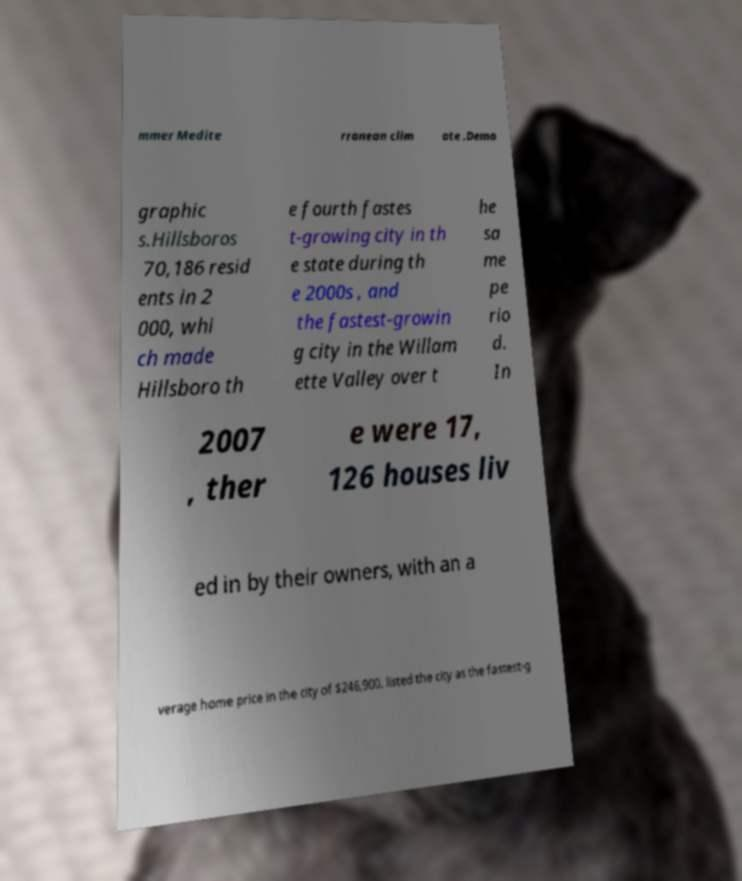Can you read and provide the text displayed in the image?This photo seems to have some interesting text. Can you extract and type it out for me? mmer Medite rranean clim ate .Demo graphic s.Hillsboros 70,186 resid ents in 2 000, whi ch made Hillsboro th e fourth fastes t-growing city in th e state during th e 2000s , and the fastest-growin g city in the Willam ette Valley over t he sa me pe rio d. In 2007 , ther e were 17, 126 houses liv ed in by their owners, with an a verage home price in the city of $246,900. listed the city as the fastest-g 